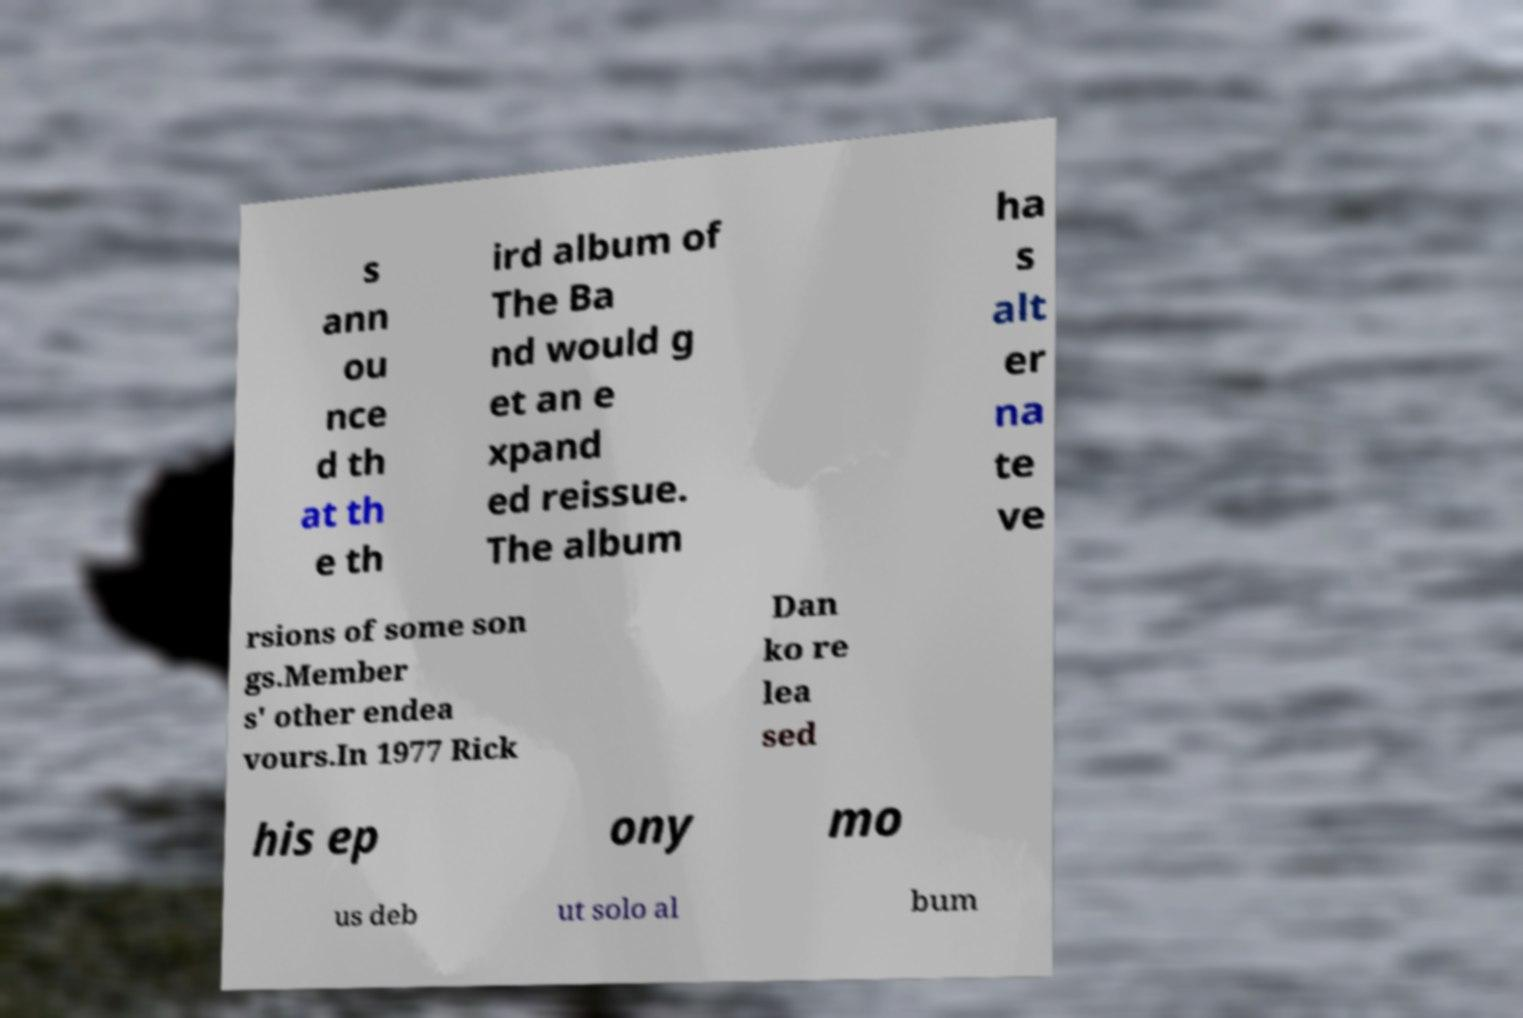Could you extract and type out the text from this image? s ann ou nce d th at th e th ird album of The Ba nd would g et an e xpand ed reissue. The album ha s alt er na te ve rsions of some son gs.Member s' other endea vours.In 1977 Rick Dan ko re lea sed his ep ony mo us deb ut solo al bum 